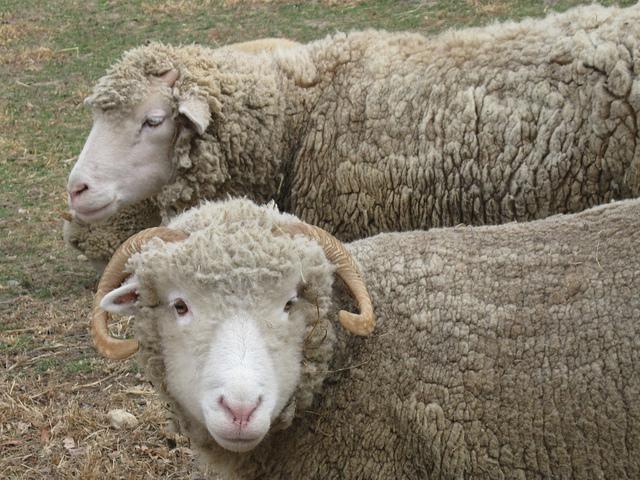How many animals are pictured?
Give a very brief answer. 2. How many sheep can be seen?
Give a very brief answer. 2. 